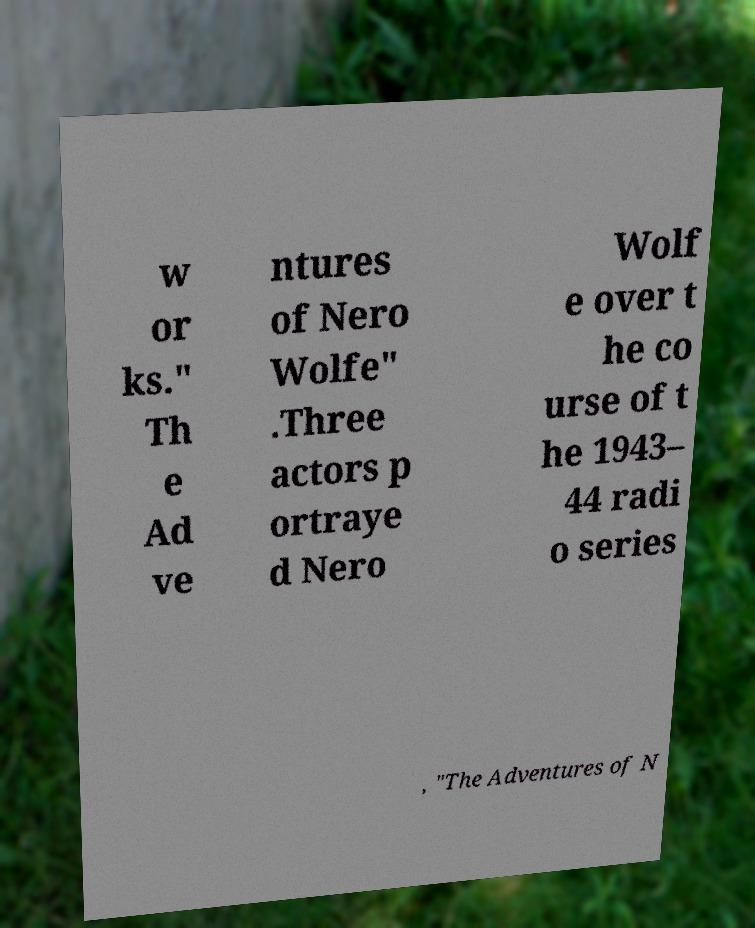Could you extract and type out the text from this image? w or ks." Th e Ad ve ntures of Nero Wolfe" .Three actors p ortraye d Nero Wolf e over t he co urse of t he 1943– 44 radi o series , "The Adventures of N 